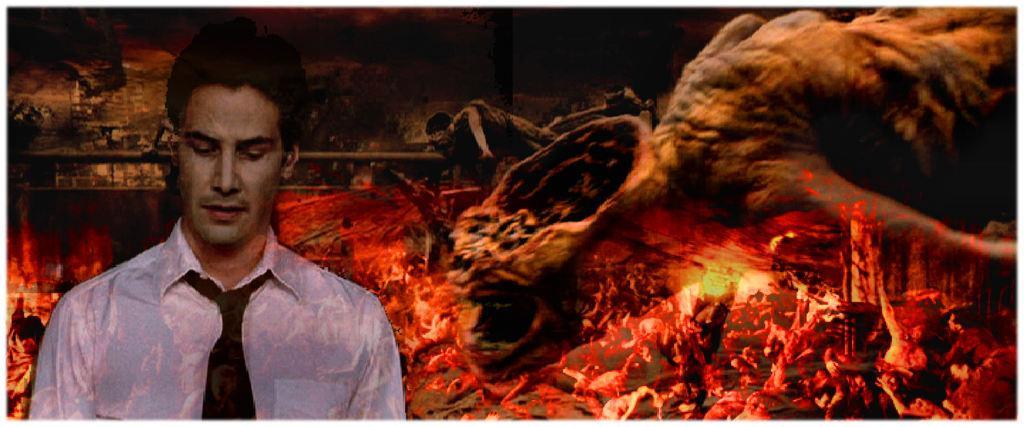Could you give a brief overview of what you see in this image? It is a graphical image in the image we can see a person and fire. 